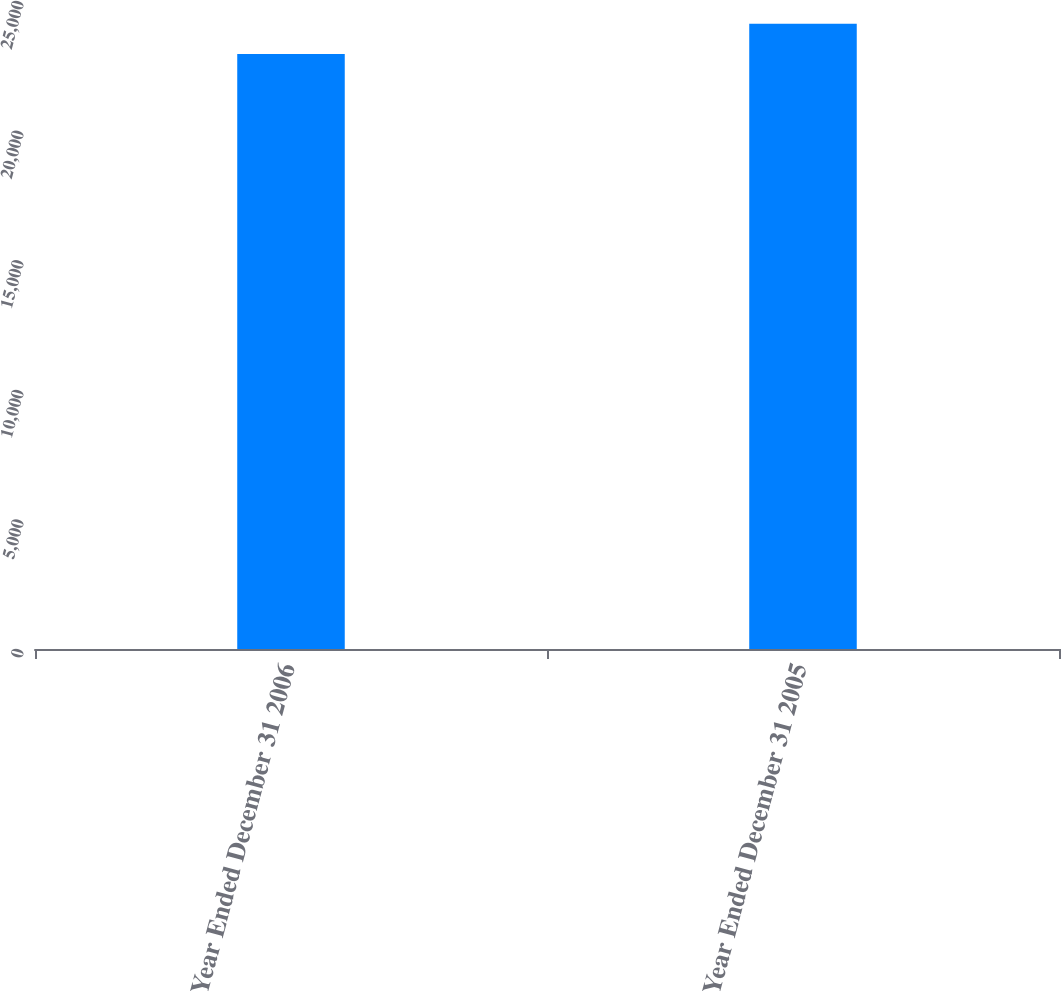Convert chart. <chart><loc_0><loc_0><loc_500><loc_500><bar_chart><fcel>Year Ended December 31 2006<fcel>Year Ended December 31 2005<nl><fcel>22958<fcel>24126<nl></chart> 